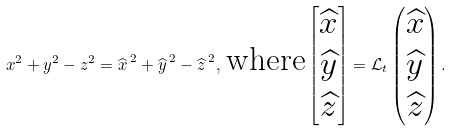<formula> <loc_0><loc_0><loc_500><loc_500>x ^ { 2 } + y ^ { 2 } - z ^ { 2 } = { \widehat { x } \, } ^ { 2 } + { \widehat { y } \, } ^ { 2 } - { \widehat { z } \, } ^ { 2 } , \, \text {where} \begin{bmatrix} \widehat { x } \\ \widehat { y } \\ \widehat { z } \end{bmatrix} = { \mathcal { L } } _ { t } \begin{pmatrix} \widehat { x } \\ \widehat { y } \\ \widehat { z } \end{pmatrix} .</formula> 